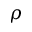Convert formula to latex. <formula><loc_0><loc_0><loc_500><loc_500>\rho</formula> 